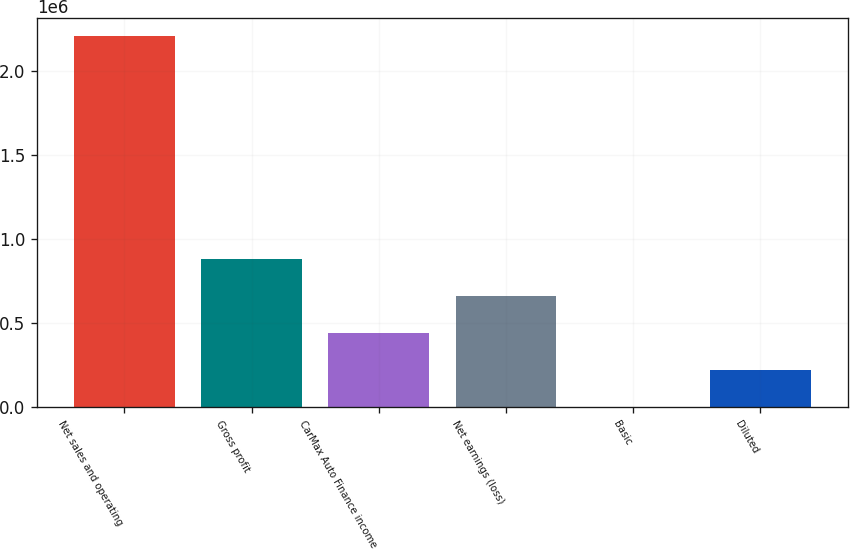Convert chart to OTSL. <chart><loc_0><loc_0><loc_500><loc_500><bar_chart><fcel>Net sales and operating<fcel>Gross profit<fcel>CarMax Auto Finance income<fcel>Net earnings (loss)<fcel>Basic<fcel>Diluted<nl><fcel>2.20876e+06<fcel>883505<fcel>441753<fcel>662629<fcel>0.13<fcel>220876<nl></chart> 